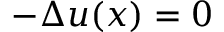Convert formula to latex. <formula><loc_0><loc_0><loc_500><loc_500>- \Delta u ( x ) = 0</formula> 